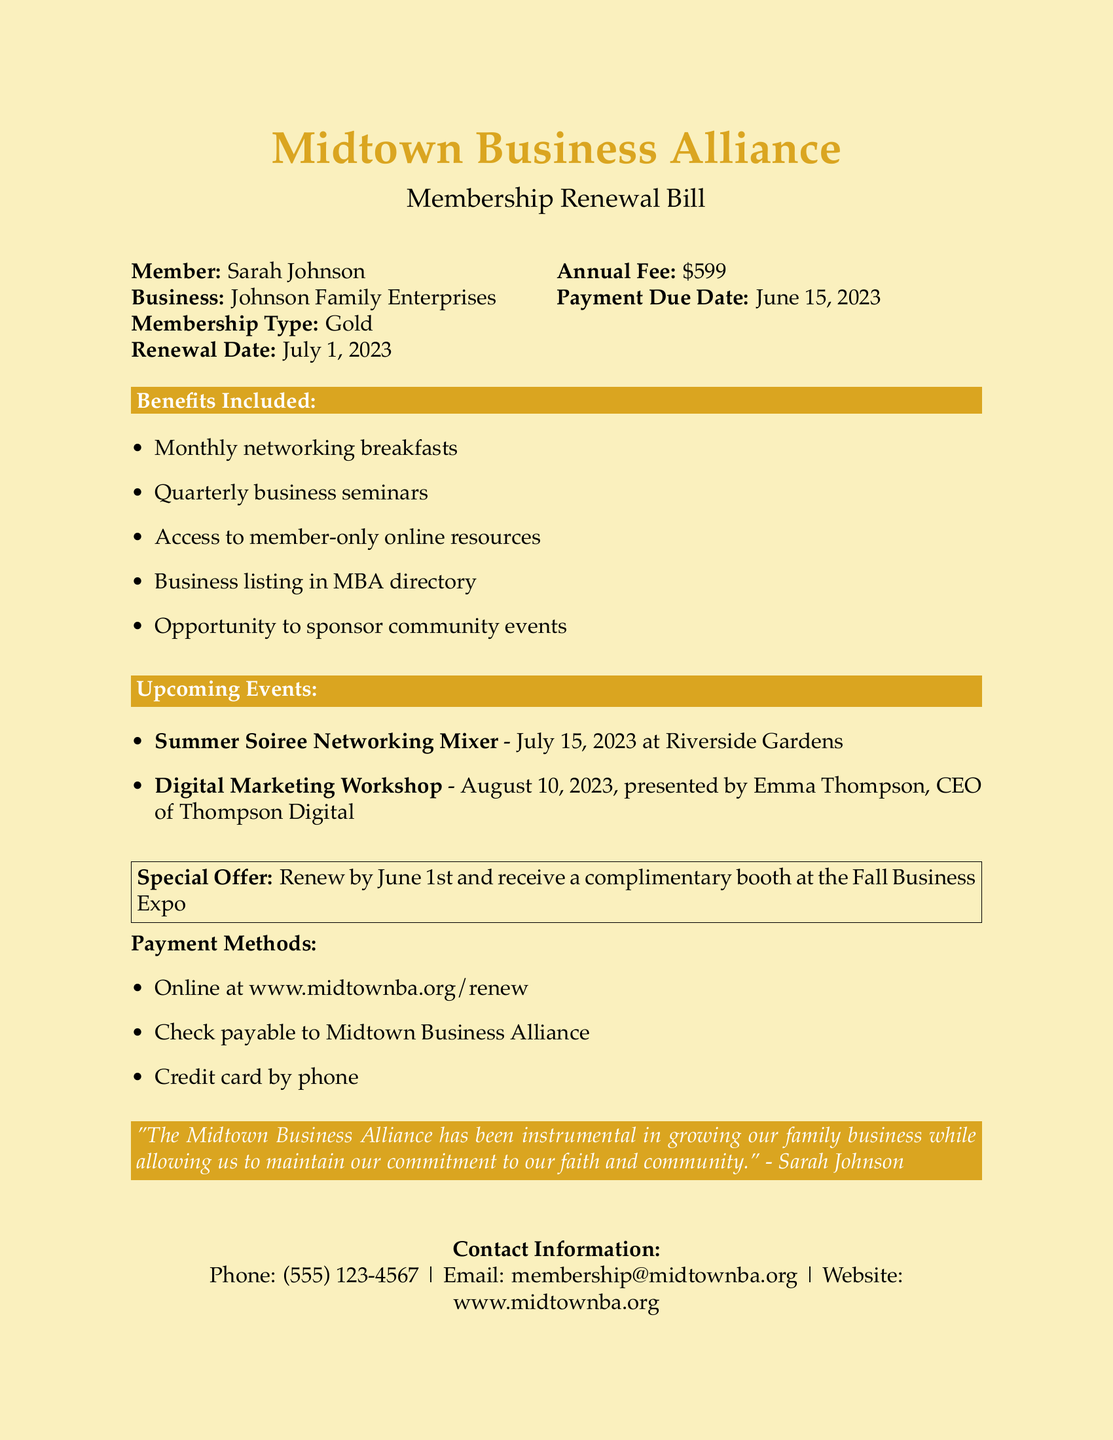What is the member's name? The member's name is listed at the top of the document in the member information section.
Answer: Sarah Johnson What is the annual fee for membership? The annual fee is clearly stated in the document and indicates the cost of the membership.
Answer: $599 When is the payment due date? The payment due date is specified in the member information section of the document.
Answer: June 15, 2023 What is one benefit included in the membership? The document lists several benefits of the membership, providing options for members.
Answer: Monthly networking breakfasts When is the Summer Soiree Networking Mixer taking place? The date of the upcoming event is noted in the events section of the document.
Answer: July 15, 2023 What is the special offer for renewing by June 1st? The special offer is stated in a boxed section and highlights an incentive for early renewal.
Answer: Complimentary booth at the Fall Business Expo How can payments be made? The document outlines several methods for making payments, indicating options available for members.
Answer: Online at www.midtownba.org/renew What type of membership does Sarah Johnson hold? The type of membership is mentioned in the member information section of the document.
Answer: Gold Who is presenting the Digital Marketing Workshop? The presenter of the workshop is specified in the description of the upcoming events section.
Answer: Emma Thompson, CEO of Thompson Digital 